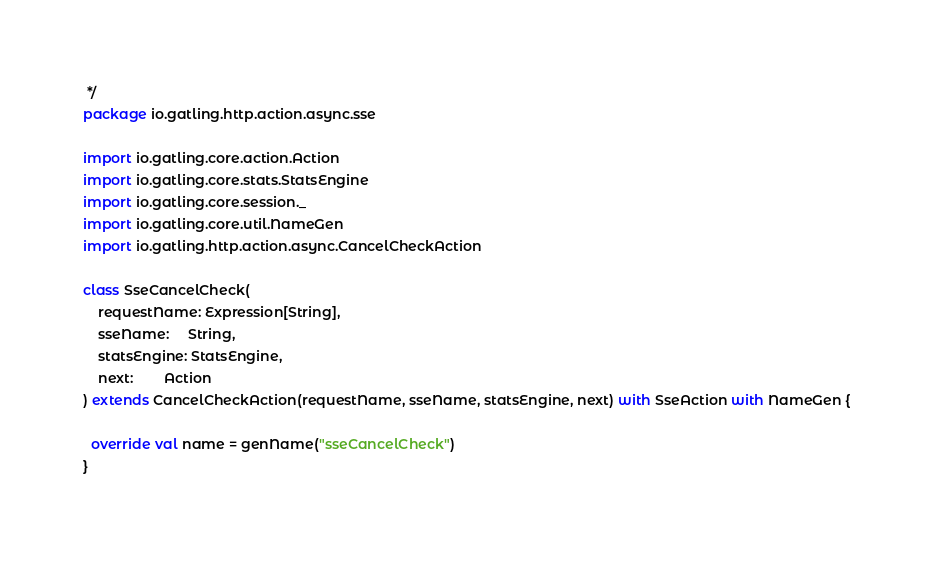Convert code to text. <code><loc_0><loc_0><loc_500><loc_500><_Scala_> */
package io.gatling.http.action.async.sse

import io.gatling.core.action.Action
import io.gatling.core.stats.StatsEngine
import io.gatling.core.session._
import io.gatling.core.util.NameGen
import io.gatling.http.action.async.CancelCheckAction

class SseCancelCheck(
    requestName: Expression[String],
    sseName:     String,
    statsEngine: StatsEngine,
    next:        Action
) extends CancelCheckAction(requestName, sseName, statsEngine, next) with SseAction with NameGen {

  override val name = genName("sseCancelCheck")
}
</code> 